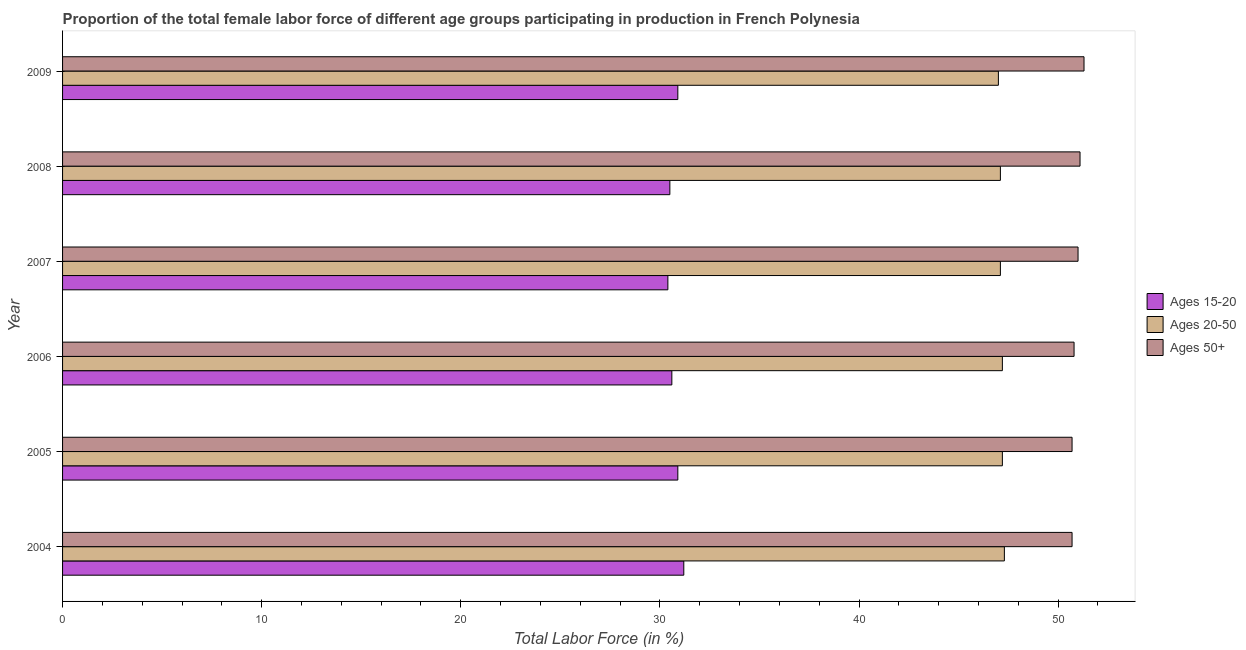How many groups of bars are there?
Give a very brief answer. 6. Are the number of bars per tick equal to the number of legend labels?
Your answer should be compact. Yes. How many bars are there on the 3rd tick from the bottom?
Keep it short and to the point. 3. In how many cases, is the number of bars for a given year not equal to the number of legend labels?
Offer a very short reply. 0. What is the percentage of female labor force above age 50 in 2005?
Ensure brevity in your answer.  50.7. Across all years, what is the maximum percentage of female labor force above age 50?
Ensure brevity in your answer.  51.3. In which year was the percentage of female labor force within the age group 20-50 maximum?
Your answer should be compact. 2004. In which year was the percentage of female labor force above age 50 minimum?
Provide a succinct answer. 2004. What is the total percentage of female labor force above age 50 in the graph?
Provide a short and direct response. 305.6. What is the difference between the percentage of female labor force above age 50 in 2006 and the percentage of female labor force within the age group 20-50 in 2009?
Your answer should be compact. 3.8. What is the average percentage of female labor force within the age group 15-20 per year?
Provide a succinct answer. 30.75. What is the ratio of the percentage of female labor force within the age group 15-20 in 2004 to that in 2009?
Offer a terse response. 1.01. What is the difference between the highest and the lowest percentage of female labor force above age 50?
Keep it short and to the point. 0.6. What does the 2nd bar from the top in 2009 represents?
Your answer should be very brief. Ages 20-50. What does the 3rd bar from the bottom in 2009 represents?
Provide a succinct answer. Ages 50+. How many bars are there?
Keep it short and to the point. 18. Are all the bars in the graph horizontal?
Ensure brevity in your answer.  Yes. How many years are there in the graph?
Make the answer very short. 6. Are the values on the major ticks of X-axis written in scientific E-notation?
Give a very brief answer. No. Does the graph contain grids?
Make the answer very short. No. Where does the legend appear in the graph?
Make the answer very short. Center right. How many legend labels are there?
Provide a short and direct response. 3. How are the legend labels stacked?
Your response must be concise. Vertical. What is the title of the graph?
Your response must be concise. Proportion of the total female labor force of different age groups participating in production in French Polynesia. Does "Transport services" appear as one of the legend labels in the graph?
Ensure brevity in your answer.  No. What is the label or title of the X-axis?
Offer a very short reply. Total Labor Force (in %). What is the label or title of the Y-axis?
Ensure brevity in your answer.  Year. What is the Total Labor Force (in %) of Ages 15-20 in 2004?
Ensure brevity in your answer.  31.2. What is the Total Labor Force (in %) in Ages 20-50 in 2004?
Provide a short and direct response. 47.3. What is the Total Labor Force (in %) in Ages 50+ in 2004?
Ensure brevity in your answer.  50.7. What is the Total Labor Force (in %) of Ages 15-20 in 2005?
Make the answer very short. 30.9. What is the Total Labor Force (in %) in Ages 20-50 in 2005?
Your answer should be compact. 47.2. What is the Total Labor Force (in %) of Ages 50+ in 2005?
Your answer should be very brief. 50.7. What is the Total Labor Force (in %) of Ages 15-20 in 2006?
Make the answer very short. 30.6. What is the Total Labor Force (in %) of Ages 20-50 in 2006?
Offer a terse response. 47.2. What is the Total Labor Force (in %) in Ages 50+ in 2006?
Keep it short and to the point. 50.8. What is the Total Labor Force (in %) of Ages 15-20 in 2007?
Make the answer very short. 30.4. What is the Total Labor Force (in %) of Ages 20-50 in 2007?
Offer a very short reply. 47.1. What is the Total Labor Force (in %) in Ages 50+ in 2007?
Keep it short and to the point. 51. What is the Total Labor Force (in %) of Ages 15-20 in 2008?
Your answer should be compact. 30.5. What is the Total Labor Force (in %) of Ages 20-50 in 2008?
Your answer should be compact. 47.1. What is the Total Labor Force (in %) in Ages 50+ in 2008?
Make the answer very short. 51.1. What is the Total Labor Force (in %) in Ages 15-20 in 2009?
Keep it short and to the point. 30.9. What is the Total Labor Force (in %) of Ages 20-50 in 2009?
Give a very brief answer. 47. What is the Total Labor Force (in %) in Ages 50+ in 2009?
Your answer should be compact. 51.3. Across all years, what is the maximum Total Labor Force (in %) in Ages 15-20?
Provide a succinct answer. 31.2. Across all years, what is the maximum Total Labor Force (in %) in Ages 20-50?
Make the answer very short. 47.3. Across all years, what is the maximum Total Labor Force (in %) in Ages 50+?
Your answer should be very brief. 51.3. Across all years, what is the minimum Total Labor Force (in %) in Ages 15-20?
Make the answer very short. 30.4. Across all years, what is the minimum Total Labor Force (in %) in Ages 20-50?
Keep it short and to the point. 47. Across all years, what is the minimum Total Labor Force (in %) in Ages 50+?
Your response must be concise. 50.7. What is the total Total Labor Force (in %) of Ages 15-20 in the graph?
Make the answer very short. 184.5. What is the total Total Labor Force (in %) of Ages 20-50 in the graph?
Give a very brief answer. 282.9. What is the total Total Labor Force (in %) of Ages 50+ in the graph?
Your answer should be very brief. 305.6. What is the difference between the Total Labor Force (in %) of Ages 20-50 in 2004 and that in 2005?
Give a very brief answer. 0.1. What is the difference between the Total Labor Force (in %) in Ages 50+ in 2004 and that in 2005?
Keep it short and to the point. 0. What is the difference between the Total Labor Force (in %) in Ages 15-20 in 2004 and that in 2006?
Provide a succinct answer. 0.6. What is the difference between the Total Labor Force (in %) in Ages 50+ in 2004 and that in 2006?
Ensure brevity in your answer.  -0.1. What is the difference between the Total Labor Force (in %) in Ages 50+ in 2004 and that in 2007?
Keep it short and to the point. -0.3. What is the difference between the Total Labor Force (in %) of Ages 50+ in 2004 and that in 2008?
Provide a short and direct response. -0.4. What is the difference between the Total Labor Force (in %) of Ages 20-50 in 2004 and that in 2009?
Offer a very short reply. 0.3. What is the difference between the Total Labor Force (in %) in Ages 50+ in 2004 and that in 2009?
Your answer should be very brief. -0.6. What is the difference between the Total Labor Force (in %) in Ages 15-20 in 2005 and that in 2006?
Your answer should be very brief. 0.3. What is the difference between the Total Labor Force (in %) of Ages 20-50 in 2005 and that in 2006?
Your response must be concise. 0. What is the difference between the Total Labor Force (in %) in Ages 50+ in 2005 and that in 2006?
Make the answer very short. -0.1. What is the difference between the Total Labor Force (in %) of Ages 50+ in 2005 and that in 2007?
Your answer should be compact. -0.3. What is the difference between the Total Labor Force (in %) in Ages 20-50 in 2005 and that in 2008?
Offer a very short reply. 0.1. What is the difference between the Total Labor Force (in %) of Ages 15-20 in 2005 and that in 2009?
Give a very brief answer. 0. What is the difference between the Total Labor Force (in %) of Ages 20-50 in 2005 and that in 2009?
Your answer should be very brief. 0.2. What is the difference between the Total Labor Force (in %) of Ages 50+ in 2006 and that in 2007?
Keep it short and to the point. -0.2. What is the difference between the Total Labor Force (in %) of Ages 15-20 in 2006 and that in 2008?
Your answer should be very brief. 0.1. What is the difference between the Total Labor Force (in %) of Ages 15-20 in 2006 and that in 2009?
Give a very brief answer. -0.3. What is the difference between the Total Labor Force (in %) of Ages 20-50 in 2006 and that in 2009?
Provide a succinct answer. 0.2. What is the difference between the Total Labor Force (in %) of Ages 50+ in 2007 and that in 2008?
Provide a succinct answer. -0.1. What is the difference between the Total Labor Force (in %) of Ages 20-50 in 2008 and that in 2009?
Make the answer very short. 0.1. What is the difference between the Total Labor Force (in %) of Ages 15-20 in 2004 and the Total Labor Force (in %) of Ages 50+ in 2005?
Your answer should be very brief. -19.5. What is the difference between the Total Labor Force (in %) in Ages 15-20 in 2004 and the Total Labor Force (in %) in Ages 50+ in 2006?
Your response must be concise. -19.6. What is the difference between the Total Labor Force (in %) of Ages 15-20 in 2004 and the Total Labor Force (in %) of Ages 20-50 in 2007?
Your answer should be very brief. -15.9. What is the difference between the Total Labor Force (in %) in Ages 15-20 in 2004 and the Total Labor Force (in %) in Ages 50+ in 2007?
Your answer should be very brief. -19.8. What is the difference between the Total Labor Force (in %) of Ages 15-20 in 2004 and the Total Labor Force (in %) of Ages 20-50 in 2008?
Keep it short and to the point. -15.9. What is the difference between the Total Labor Force (in %) in Ages 15-20 in 2004 and the Total Labor Force (in %) in Ages 50+ in 2008?
Provide a short and direct response. -19.9. What is the difference between the Total Labor Force (in %) in Ages 15-20 in 2004 and the Total Labor Force (in %) in Ages 20-50 in 2009?
Offer a terse response. -15.8. What is the difference between the Total Labor Force (in %) in Ages 15-20 in 2004 and the Total Labor Force (in %) in Ages 50+ in 2009?
Offer a very short reply. -20.1. What is the difference between the Total Labor Force (in %) in Ages 15-20 in 2005 and the Total Labor Force (in %) in Ages 20-50 in 2006?
Offer a terse response. -16.3. What is the difference between the Total Labor Force (in %) of Ages 15-20 in 2005 and the Total Labor Force (in %) of Ages 50+ in 2006?
Your answer should be compact. -19.9. What is the difference between the Total Labor Force (in %) of Ages 20-50 in 2005 and the Total Labor Force (in %) of Ages 50+ in 2006?
Offer a terse response. -3.6. What is the difference between the Total Labor Force (in %) of Ages 15-20 in 2005 and the Total Labor Force (in %) of Ages 20-50 in 2007?
Keep it short and to the point. -16.2. What is the difference between the Total Labor Force (in %) in Ages 15-20 in 2005 and the Total Labor Force (in %) in Ages 50+ in 2007?
Provide a short and direct response. -20.1. What is the difference between the Total Labor Force (in %) in Ages 20-50 in 2005 and the Total Labor Force (in %) in Ages 50+ in 2007?
Provide a short and direct response. -3.8. What is the difference between the Total Labor Force (in %) of Ages 15-20 in 2005 and the Total Labor Force (in %) of Ages 20-50 in 2008?
Ensure brevity in your answer.  -16.2. What is the difference between the Total Labor Force (in %) of Ages 15-20 in 2005 and the Total Labor Force (in %) of Ages 50+ in 2008?
Provide a short and direct response. -20.2. What is the difference between the Total Labor Force (in %) in Ages 20-50 in 2005 and the Total Labor Force (in %) in Ages 50+ in 2008?
Offer a terse response. -3.9. What is the difference between the Total Labor Force (in %) of Ages 15-20 in 2005 and the Total Labor Force (in %) of Ages 20-50 in 2009?
Make the answer very short. -16.1. What is the difference between the Total Labor Force (in %) of Ages 15-20 in 2005 and the Total Labor Force (in %) of Ages 50+ in 2009?
Make the answer very short. -20.4. What is the difference between the Total Labor Force (in %) of Ages 15-20 in 2006 and the Total Labor Force (in %) of Ages 20-50 in 2007?
Your answer should be compact. -16.5. What is the difference between the Total Labor Force (in %) in Ages 15-20 in 2006 and the Total Labor Force (in %) in Ages 50+ in 2007?
Offer a very short reply. -20.4. What is the difference between the Total Labor Force (in %) in Ages 15-20 in 2006 and the Total Labor Force (in %) in Ages 20-50 in 2008?
Provide a succinct answer. -16.5. What is the difference between the Total Labor Force (in %) of Ages 15-20 in 2006 and the Total Labor Force (in %) of Ages 50+ in 2008?
Ensure brevity in your answer.  -20.5. What is the difference between the Total Labor Force (in %) in Ages 20-50 in 2006 and the Total Labor Force (in %) in Ages 50+ in 2008?
Your answer should be compact. -3.9. What is the difference between the Total Labor Force (in %) in Ages 15-20 in 2006 and the Total Labor Force (in %) in Ages 20-50 in 2009?
Your answer should be very brief. -16.4. What is the difference between the Total Labor Force (in %) of Ages 15-20 in 2006 and the Total Labor Force (in %) of Ages 50+ in 2009?
Make the answer very short. -20.7. What is the difference between the Total Labor Force (in %) in Ages 15-20 in 2007 and the Total Labor Force (in %) in Ages 20-50 in 2008?
Your answer should be compact. -16.7. What is the difference between the Total Labor Force (in %) in Ages 15-20 in 2007 and the Total Labor Force (in %) in Ages 50+ in 2008?
Give a very brief answer. -20.7. What is the difference between the Total Labor Force (in %) of Ages 20-50 in 2007 and the Total Labor Force (in %) of Ages 50+ in 2008?
Your answer should be compact. -4. What is the difference between the Total Labor Force (in %) of Ages 15-20 in 2007 and the Total Labor Force (in %) of Ages 20-50 in 2009?
Provide a short and direct response. -16.6. What is the difference between the Total Labor Force (in %) in Ages 15-20 in 2007 and the Total Labor Force (in %) in Ages 50+ in 2009?
Offer a very short reply. -20.9. What is the difference between the Total Labor Force (in %) of Ages 20-50 in 2007 and the Total Labor Force (in %) of Ages 50+ in 2009?
Ensure brevity in your answer.  -4.2. What is the difference between the Total Labor Force (in %) of Ages 15-20 in 2008 and the Total Labor Force (in %) of Ages 20-50 in 2009?
Make the answer very short. -16.5. What is the difference between the Total Labor Force (in %) in Ages 15-20 in 2008 and the Total Labor Force (in %) in Ages 50+ in 2009?
Give a very brief answer. -20.8. What is the difference between the Total Labor Force (in %) in Ages 20-50 in 2008 and the Total Labor Force (in %) in Ages 50+ in 2009?
Make the answer very short. -4.2. What is the average Total Labor Force (in %) of Ages 15-20 per year?
Your answer should be compact. 30.75. What is the average Total Labor Force (in %) of Ages 20-50 per year?
Your response must be concise. 47.15. What is the average Total Labor Force (in %) in Ages 50+ per year?
Ensure brevity in your answer.  50.93. In the year 2004, what is the difference between the Total Labor Force (in %) of Ages 15-20 and Total Labor Force (in %) of Ages 20-50?
Make the answer very short. -16.1. In the year 2004, what is the difference between the Total Labor Force (in %) in Ages 15-20 and Total Labor Force (in %) in Ages 50+?
Make the answer very short. -19.5. In the year 2005, what is the difference between the Total Labor Force (in %) in Ages 15-20 and Total Labor Force (in %) in Ages 20-50?
Provide a succinct answer. -16.3. In the year 2005, what is the difference between the Total Labor Force (in %) of Ages 15-20 and Total Labor Force (in %) of Ages 50+?
Offer a terse response. -19.8. In the year 2005, what is the difference between the Total Labor Force (in %) in Ages 20-50 and Total Labor Force (in %) in Ages 50+?
Ensure brevity in your answer.  -3.5. In the year 2006, what is the difference between the Total Labor Force (in %) in Ages 15-20 and Total Labor Force (in %) in Ages 20-50?
Offer a very short reply. -16.6. In the year 2006, what is the difference between the Total Labor Force (in %) in Ages 15-20 and Total Labor Force (in %) in Ages 50+?
Your answer should be compact. -20.2. In the year 2007, what is the difference between the Total Labor Force (in %) of Ages 15-20 and Total Labor Force (in %) of Ages 20-50?
Ensure brevity in your answer.  -16.7. In the year 2007, what is the difference between the Total Labor Force (in %) in Ages 15-20 and Total Labor Force (in %) in Ages 50+?
Your answer should be compact. -20.6. In the year 2007, what is the difference between the Total Labor Force (in %) in Ages 20-50 and Total Labor Force (in %) in Ages 50+?
Provide a short and direct response. -3.9. In the year 2008, what is the difference between the Total Labor Force (in %) of Ages 15-20 and Total Labor Force (in %) of Ages 20-50?
Provide a short and direct response. -16.6. In the year 2008, what is the difference between the Total Labor Force (in %) in Ages 15-20 and Total Labor Force (in %) in Ages 50+?
Provide a succinct answer. -20.6. In the year 2008, what is the difference between the Total Labor Force (in %) of Ages 20-50 and Total Labor Force (in %) of Ages 50+?
Ensure brevity in your answer.  -4. In the year 2009, what is the difference between the Total Labor Force (in %) of Ages 15-20 and Total Labor Force (in %) of Ages 20-50?
Provide a succinct answer. -16.1. In the year 2009, what is the difference between the Total Labor Force (in %) of Ages 15-20 and Total Labor Force (in %) of Ages 50+?
Keep it short and to the point. -20.4. What is the ratio of the Total Labor Force (in %) of Ages 15-20 in 2004 to that in 2005?
Make the answer very short. 1.01. What is the ratio of the Total Labor Force (in %) of Ages 20-50 in 2004 to that in 2005?
Give a very brief answer. 1. What is the ratio of the Total Labor Force (in %) of Ages 50+ in 2004 to that in 2005?
Give a very brief answer. 1. What is the ratio of the Total Labor Force (in %) of Ages 15-20 in 2004 to that in 2006?
Make the answer very short. 1.02. What is the ratio of the Total Labor Force (in %) of Ages 20-50 in 2004 to that in 2006?
Ensure brevity in your answer.  1. What is the ratio of the Total Labor Force (in %) in Ages 15-20 in 2004 to that in 2007?
Provide a succinct answer. 1.03. What is the ratio of the Total Labor Force (in %) of Ages 15-20 in 2004 to that in 2008?
Offer a terse response. 1.02. What is the ratio of the Total Labor Force (in %) of Ages 20-50 in 2004 to that in 2008?
Your response must be concise. 1. What is the ratio of the Total Labor Force (in %) in Ages 15-20 in 2004 to that in 2009?
Offer a terse response. 1.01. What is the ratio of the Total Labor Force (in %) of Ages 20-50 in 2004 to that in 2009?
Provide a succinct answer. 1.01. What is the ratio of the Total Labor Force (in %) in Ages 50+ in 2004 to that in 2009?
Provide a short and direct response. 0.99. What is the ratio of the Total Labor Force (in %) of Ages 15-20 in 2005 to that in 2006?
Offer a very short reply. 1.01. What is the ratio of the Total Labor Force (in %) of Ages 20-50 in 2005 to that in 2006?
Your answer should be very brief. 1. What is the ratio of the Total Labor Force (in %) in Ages 15-20 in 2005 to that in 2007?
Provide a short and direct response. 1.02. What is the ratio of the Total Labor Force (in %) of Ages 20-50 in 2005 to that in 2007?
Offer a terse response. 1. What is the ratio of the Total Labor Force (in %) of Ages 15-20 in 2005 to that in 2008?
Offer a very short reply. 1.01. What is the ratio of the Total Labor Force (in %) in Ages 20-50 in 2005 to that in 2008?
Ensure brevity in your answer.  1. What is the ratio of the Total Labor Force (in %) of Ages 50+ in 2005 to that in 2008?
Your answer should be very brief. 0.99. What is the ratio of the Total Labor Force (in %) in Ages 50+ in 2005 to that in 2009?
Provide a succinct answer. 0.99. What is the ratio of the Total Labor Force (in %) of Ages 15-20 in 2006 to that in 2007?
Keep it short and to the point. 1.01. What is the ratio of the Total Labor Force (in %) of Ages 50+ in 2006 to that in 2007?
Your response must be concise. 1. What is the ratio of the Total Labor Force (in %) of Ages 15-20 in 2006 to that in 2008?
Your answer should be very brief. 1. What is the ratio of the Total Labor Force (in %) in Ages 15-20 in 2006 to that in 2009?
Offer a terse response. 0.99. What is the ratio of the Total Labor Force (in %) in Ages 50+ in 2006 to that in 2009?
Your answer should be compact. 0.99. What is the ratio of the Total Labor Force (in %) in Ages 20-50 in 2007 to that in 2008?
Provide a short and direct response. 1. What is the ratio of the Total Labor Force (in %) of Ages 50+ in 2007 to that in 2008?
Keep it short and to the point. 1. What is the ratio of the Total Labor Force (in %) of Ages 15-20 in 2007 to that in 2009?
Your answer should be very brief. 0.98. What is the ratio of the Total Labor Force (in %) in Ages 20-50 in 2007 to that in 2009?
Keep it short and to the point. 1. What is the ratio of the Total Labor Force (in %) of Ages 15-20 in 2008 to that in 2009?
Your answer should be compact. 0.99. What is the ratio of the Total Labor Force (in %) in Ages 50+ in 2008 to that in 2009?
Ensure brevity in your answer.  1. What is the difference between the highest and the second highest Total Labor Force (in %) of Ages 15-20?
Give a very brief answer. 0.3. What is the difference between the highest and the second highest Total Labor Force (in %) in Ages 50+?
Offer a terse response. 0.2. What is the difference between the highest and the lowest Total Labor Force (in %) in Ages 20-50?
Your answer should be very brief. 0.3. 